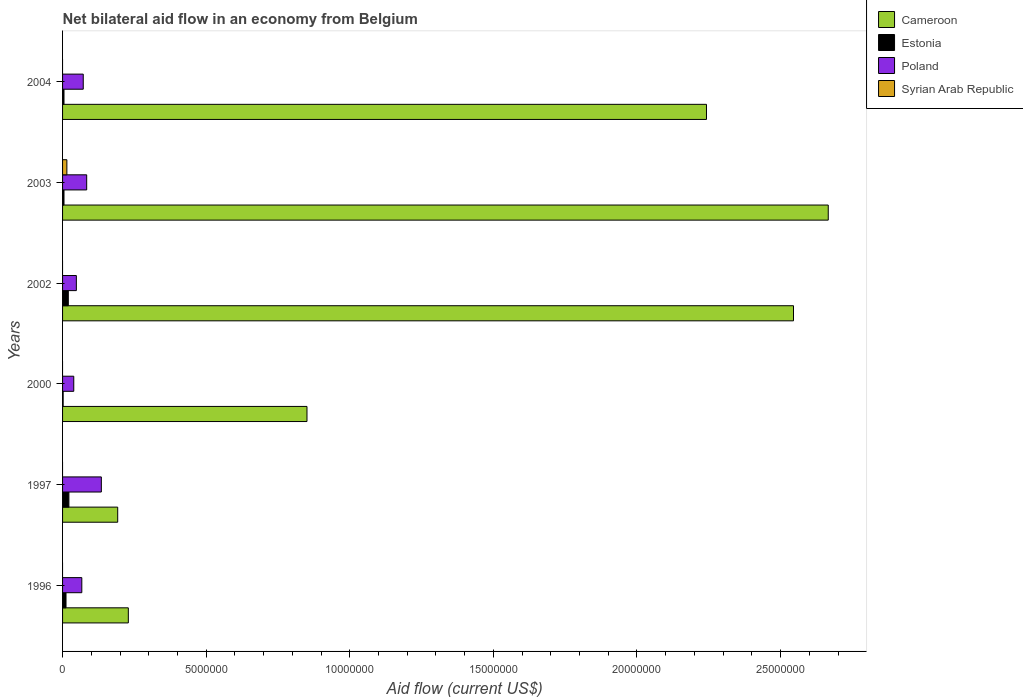How many different coloured bars are there?
Provide a short and direct response. 4. How many groups of bars are there?
Provide a short and direct response. 6. In how many cases, is the number of bars for a given year not equal to the number of legend labels?
Your response must be concise. 5. What is the net bilateral aid flow in Cameroon in 2003?
Offer a terse response. 2.67e+07. What is the total net bilateral aid flow in Cameroon in the graph?
Give a very brief answer. 8.72e+07. What is the average net bilateral aid flow in Cameroon per year?
Keep it short and to the point. 1.45e+07. In the year 2003, what is the difference between the net bilateral aid flow in Poland and net bilateral aid flow in Syrian Arab Republic?
Give a very brief answer. 6.90e+05. In how many years, is the net bilateral aid flow in Cameroon greater than 2000000 US$?
Offer a very short reply. 5. What is the ratio of the net bilateral aid flow in Cameroon in 1997 to that in 2003?
Provide a succinct answer. 0.07. Is the net bilateral aid flow in Estonia in 2000 less than that in 2004?
Keep it short and to the point. Yes. What is the difference between the highest and the second highest net bilateral aid flow in Cameroon?
Offer a very short reply. 1.21e+06. What is the difference between the highest and the lowest net bilateral aid flow in Estonia?
Offer a very short reply. 2.00e+05. In how many years, is the net bilateral aid flow in Estonia greater than the average net bilateral aid flow in Estonia taken over all years?
Make the answer very short. 3. Is it the case that in every year, the sum of the net bilateral aid flow in Estonia and net bilateral aid flow in Syrian Arab Republic is greater than the sum of net bilateral aid flow in Poland and net bilateral aid flow in Cameroon?
Your answer should be compact. No. Is it the case that in every year, the sum of the net bilateral aid flow in Cameroon and net bilateral aid flow in Poland is greater than the net bilateral aid flow in Syrian Arab Republic?
Offer a very short reply. Yes. How many bars are there?
Make the answer very short. 19. Are all the bars in the graph horizontal?
Offer a very short reply. Yes. How many years are there in the graph?
Ensure brevity in your answer.  6. Are the values on the major ticks of X-axis written in scientific E-notation?
Provide a succinct answer. No. Does the graph contain any zero values?
Ensure brevity in your answer.  Yes. Where does the legend appear in the graph?
Offer a very short reply. Top right. How many legend labels are there?
Your answer should be very brief. 4. How are the legend labels stacked?
Keep it short and to the point. Vertical. What is the title of the graph?
Provide a succinct answer. Net bilateral aid flow in an economy from Belgium. What is the label or title of the Y-axis?
Offer a very short reply. Years. What is the Aid flow (current US$) in Cameroon in 1996?
Keep it short and to the point. 2.29e+06. What is the Aid flow (current US$) in Poland in 1996?
Offer a very short reply. 6.70e+05. What is the Aid flow (current US$) in Syrian Arab Republic in 1996?
Your answer should be very brief. 0. What is the Aid flow (current US$) in Cameroon in 1997?
Your answer should be compact. 1.92e+06. What is the Aid flow (current US$) in Poland in 1997?
Your response must be concise. 1.35e+06. What is the Aid flow (current US$) of Cameroon in 2000?
Provide a short and direct response. 8.51e+06. What is the Aid flow (current US$) in Estonia in 2000?
Keep it short and to the point. 2.00e+04. What is the Aid flow (current US$) in Poland in 2000?
Keep it short and to the point. 3.90e+05. What is the Aid flow (current US$) in Cameroon in 2002?
Offer a very short reply. 2.54e+07. What is the Aid flow (current US$) of Syrian Arab Republic in 2002?
Your answer should be compact. 0. What is the Aid flow (current US$) in Cameroon in 2003?
Offer a terse response. 2.67e+07. What is the Aid flow (current US$) of Poland in 2003?
Provide a short and direct response. 8.40e+05. What is the Aid flow (current US$) in Syrian Arab Republic in 2003?
Offer a very short reply. 1.50e+05. What is the Aid flow (current US$) of Cameroon in 2004?
Give a very brief answer. 2.24e+07. What is the Aid flow (current US$) in Estonia in 2004?
Offer a terse response. 5.00e+04. What is the Aid flow (current US$) in Poland in 2004?
Your answer should be compact. 7.20e+05. What is the Aid flow (current US$) in Syrian Arab Republic in 2004?
Offer a terse response. 0. Across all years, what is the maximum Aid flow (current US$) of Cameroon?
Give a very brief answer. 2.67e+07. Across all years, what is the maximum Aid flow (current US$) in Poland?
Give a very brief answer. 1.35e+06. Across all years, what is the maximum Aid flow (current US$) in Syrian Arab Republic?
Give a very brief answer. 1.50e+05. Across all years, what is the minimum Aid flow (current US$) in Cameroon?
Keep it short and to the point. 1.92e+06. What is the total Aid flow (current US$) in Cameroon in the graph?
Keep it short and to the point. 8.72e+07. What is the total Aid flow (current US$) in Poland in the graph?
Provide a succinct answer. 4.45e+06. What is the total Aid flow (current US$) in Syrian Arab Republic in the graph?
Keep it short and to the point. 1.50e+05. What is the difference between the Aid flow (current US$) of Cameroon in 1996 and that in 1997?
Keep it short and to the point. 3.70e+05. What is the difference between the Aid flow (current US$) in Estonia in 1996 and that in 1997?
Ensure brevity in your answer.  -1.00e+05. What is the difference between the Aid flow (current US$) of Poland in 1996 and that in 1997?
Provide a short and direct response. -6.80e+05. What is the difference between the Aid flow (current US$) in Cameroon in 1996 and that in 2000?
Make the answer very short. -6.22e+06. What is the difference between the Aid flow (current US$) of Cameroon in 1996 and that in 2002?
Keep it short and to the point. -2.32e+07. What is the difference between the Aid flow (current US$) in Poland in 1996 and that in 2002?
Keep it short and to the point. 1.90e+05. What is the difference between the Aid flow (current US$) of Cameroon in 1996 and that in 2003?
Offer a terse response. -2.44e+07. What is the difference between the Aid flow (current US$) of Poland in 1996 and that in 2003?
Provide a succinct answer. -1.70e+05. What is the difference between the Aid flow (current US$) of Cameroon in 1996 and that in 2004?
Offer a terse response. -2.01e+07. What is the difference between the Aid flow (current US$) in Estonia in 1996 and that in 2004?
Give a very brief answer. 7.00e+04. What is the difference between the Aid flow (current US$) of Poland in 1996 and that in 2004?
Keep it short and to the point. -5.00e+04. What is the difference between the Aid flow (current US$) of Cameroon in 1997 and that in 2000?
Give a very brief answer. -6.59e+06. What is the difference between the Aid flow (current US$) of Estonia in 1997 and that in 2000?
Your response must be concise. 2.00e+05. What is the difference between the Aid flow (current US$) of Poland in 1997 and that in 2000?
Your answer should be compact. 9.60e+05. What is the difference between the Aid flow (current US$) of Cameroon in 1997 and that in 2002?
Ensure brevity in your answer.  -2.35e+07. What is the difference between the Aid flow (current US$) of Poland in 1997 and that in 2002?
Your response must be concise. 8.70e+05. What is the difference between the Aid flow (current US$) in Cameroon in 1997 and that in 2003?
Make the answer very short. -2.47e+07. What is the difference between the Aid flow (current US$) of Poland in 1997 and that in 2003?
Offer a very short reply. 5.10e+05. What is the difference between the Aid flow (current US$) of Cameroon in 1997 and that in 2004?
Make the answer very short. -2.05e+07. What is the difference between the Aid flow (current US$) in Poland in 1997 and that in 2004?
Provide a succinct answer. 6.30e+05. What is the difference between the Aid flow (current US$) in Cameroon in 2000 and that in 2002?
Offer a very short reply. -1.69e+07. What is the difference between the Aid flow (current US$) of Estonia in 2000 and that in 2002?
Give a very brief answer. -1.80e+05. What is the difference between the Aid flow (current US$) of Cameroon in 2000 and that in 2003?
Keep it short and to the point. -1.82e+07. What is the difference between the Aid flow (current US$) in Poland in 2000 and that in 2003?
Give a very brief answer. -4.50e+05. What is the difference between the Aid flow (current US$) of Cameroon in 2000 and that in 2004?
Make the answer very short. -1.39e+07. What is the difference between the Aid flow (current US$) in Poland in 2000 and that in 2004?
Your answer should be compact. -3.30e+05. What is the difference between the Aid flow (current US$) in Cameroon in 2002 and that in 2003?
Offer a terse response. -1.21e+06. What is the difference between the Aid flow (current US$) in Poland in 2002 and that in 2003?
Offer a terse response. -3.60e+05. What is the difference between the Aid flow (current US$) of Cameroon in 2002 and that in 2004?
Make the answer very short. 3.03e+06. What is the difference between the Aid flow (current US$) in Poland in 2002 and that in 2004?
Offer a terse response. -2.40e+05. What is the difference between the Aid flow (current US$) of Cameroon in 2003 and that in 2004?
Offer a terse response. 4.24e+06. What is the difference between the Aid flow (current US$) of Estonia in 2003 and that in 2004?
Make the answer very short. 0. What is the difference between the Aid flow (current US$) in Cameroon in 1996 and the Aid flow (current US$) in Estonia in 1997?
Give a very brief answer. 2.07e+06. What is the difference between the Aid flow (current US$) in Cameroon in 1996 and the Aid flow (current US$) in Poland in 1997?
Ensure brevity in your answer.  9.40e+05. What is the difference between the Aid flow (current US$) in Estonia in 1996 and the Aid flow (current US$) in Poland in 1997?
Keep it short and to the point. -1.23e+06. What is the difference between the Aid flow (current US$) of Cameroon in 1996 and the Aid flow (current US$) of Estonia in 2000?
Your response must be concise. 2.27e+06. What is the difference between the Aid flow (current US$) in Cameroon in 1996 and the Aid flow (current US$) in Poland in 2000?
Give a very brief answer. 1.90e+06. What is the difference between the Aid flow (current US$) of Estonia in 1996 and the Aid flow (current US$) of Poland in 2000?
Give a very brief answer. -2.70e+05. What is the difference between the Aid flow (current US$) in Cameroon in 1996 and the Aid flow (current US$) in Estonia in 2002?
Your response must be concise. 2.09e+06. What is the difference between the Aid flow (current US$) of Cameroon in 1996 and the Aid flow (current US$) of Poland in 2002?
Offer a very short reply. 1.81e+06. What is the difference between the Aid flow (current US$) in Estonia in 1996 and the Aid flow (current US$) in Poland in 2002?
Your answer should be compact. -3.60e+05. What is the difference between the Aid flow (current US$) of Cameroon in 1996 and the Aid flow (current US$) of Estonia in 2003?
Make the answer very short. 2.24e+06. What is the difference between the Aid flow (current US$) of Cameroon in 1996 and the Aid flow (current US$) of Poland in 2003?
Offer a very short reply. 1.45e+06. What is the difference between the Aid flow (current US$) in Cameroon in 1996 and the Aid flow (current US$) in Syrian Arab Republic in 2003?
Your answer should be very brief. 2.14e+06. What is the difference between the Aid flow (current US$) of Estonia in 1996 and the Aid flow (current US$) of Poland in 2003?
Offer a very short reply. -7.20e+05. What is the difference between the Aid flow (current US$) in Estonia in 1996 and the Aid flow (current US$) in Syrian Arab Republic in 2003?
Your response must be concise. -3.00e+04. What is the difference between the Aid flow (current US$) of Poland in 1996 and the Aid flow (current US$) of Syrian Arab Republic in 2003?
Ensure brevity in your answer.  5.20e+05. What is the difference between the Aid flow (current US$) of Cameroon in 1996 and the Aid flow (current US$) of Estonia in 2004?
Make the answer very short. 2.24e+06. What is the difference between the Aid flow (current US$) of Cameroon in 1996 and the Aid flow (current US$) of Poland in 2004?
Give a very brief answer. 1.57e+06. What is the difference between the Aid flow (current US$) in Estonia in 1996 and the Aid flow (current US$) in Poland in 2004?
Give a very brief answer. -6.00e+05. What is the difference between the Aid flow (current US$) in Cameroon in 1997 and the Aid flow (current US$) in Estonia in 2000?
Ensure brevity in your answer.  1.90e+06. What is the difference between the Aid flow (current US$) of Cameroon in 1997 and the Aid flow (current US$) of Poland in 2000?
Provide a short and direct response. 1.53e+06. What is the difference between the Aid flow (current US$) in Estonia in 1997 and the Aid flow (current US$) in Poland in 2000?
Make the answer very short. -1.70e+05. What is the difference between the Aid flow (current US$) of Cameroon in 1997 and the Aid flow (current US$) of Estonia in 2002?
Keep it short and to the point. 1.72e+06. What is the difference between the Aid flow (current US$) in Cameroon in 1997 and the Aid flow (current US$) in Poland in 2002?
Your answer should be very brief. 1.44e+06. What is the difference between the Aid flow (current US$) in Estonia in 1997 and the Aid flow (current US$) in Poland in 2002?
Offer a very short reply. -2.60e+05. What is the difference between the Aid flow (current US$) in Cameroon in 1997 and the Aid flow (current US$) in Estonia in 2003?
Your response must be concise. 1.87e+06. What is the difference between the Aid flow (current US$) in Cameroon in 1997 and the Aid flow (current US$) in Poland in 2003?
Your answer should be very brief. 1.08e+06. What is the difference between the Aid flow (current US$) in Cameroon in 1997 and the Aid flow (current US$) in Syrian Arab Republic in 2003?
Offer a very short reply. 1.77e+06. What is the difference between the Aid flow (current US$) of Estonia in 1997 and the Aid flow (current US$) of Poland in 2003?
Ensure brevity in your answer.  -6.20e+05. What is the difference between the Aid flow (current US$) of Estonia in 1997 and the Aid flow (current US$) of Syrian Arab Republic in 2003?
Make the answer very short. 7.00e+04. What is the difference between the Aid flow (current US$) of Poland in 1997 and the Aid flow (current US$) of Syrian Arab Republic in 2003?
Offer a terse response. 1.20e+06. What is the difference between the Aid flow (current US$) in Cameroon in 1997 and the Aid flow (current US$) in Estonia in 2004?
Offer a very short reply. 1.87e+06. What is the difference between the Aid flow (current US$) of Cameroon in 1997 and the Aid flow (current US$) of Poland in 2004?
Ensure brevity in your answer.  1.20e+06. What is the difference between the Aid flow (current US$) of Estonia in 1997 and the Aid flow (current US$) of Poland in 2004?
Your answer should be compact. -5.00e+05. What is the difference between the Aid flow (current US$) of Cameroon in 2000 and the Aid flow (current US$) of Estonia in 2002?
Your response must be concise. 8.31e+06. What is the difference between the Aid flow (current US$) in Cameroon in 2000 and the Aid flow (current US$) in Poland in 2002?
Offer a very short reply. 8.03e+06. What is the difference between the Aid flow (current US$) in Estonia in 2000 and the Aid flow (current US$) in Poland in 2002?
Offer a terse response. -4.60e+05. What is the difference between the Aid flow (current US$) of Cameroon in 2000 and the Aid flow (current US$) of Estonia in 2003?
Keep it short and to the point. 8.46e+06. What is the difference between the Aid flow (current US$) of Cameroon in 2000 and the Aid flow (current US$) of Poland in 2003?
Ensure brevity in your answer.  7.67e+06. What is the difference between the Aid flow (current US$) in Cameroon in 2000 and the Aid flow (current US$) in Syrian Arab Republic in 2003?
Your response must be concise. 8.36e+06. What is the difference between the Aid flow (current US$) of Estonia in 2000 and the Aid flow (current US$) of Poland in 2003?
Give a very brief answer. -8.20e+05. What is the difference between the Aid flow (current US$) of Estonia in 2000 and the Aid flow (current US$) of Syrian Arab Republic in 2003?
Give a very brief answer. -1.30e+05. What is the difference between the Aid flow (current US$) in Cameroon in 2000 and the Aid flow (current US$) in Estonia in 2004?
Make the answer very short. 8.46e+06. What is the difference between the Aid flow (current US$) in Cameroon in 2000 and the Aid flow (current US$) in Poland in 2004?
Provide a short and direct response. 7.79e+06. What is the difference between the Aid flow (current US$) in Estonia in 2000 and the Aid flow (current US$) in Poland in 2004?
Your response must be concise. -7.00e+05. What is the difference between the Aid flow (current US$) in Cameroon in 2002 and the Aid flow (current US$) in Estonia in 2003?
Keep it short and to the point. 2.54e+07. What is the difference between the Aid flow (current US$) in Cameroon in 2002 and the Aid flow (current US$) in Poland in 2003?
Make the answer very short. 2.46e+07. What is the difference between the Aid flow (current US$) in Cameroon in 2002 and the Aid flow (current US$) in Syrian Arab Republic in 2003?
Make the answer very short. 2.53e+07. What is the difference between the Aid flow (current US$) of Estonia in 2002 and the Aid flow (current US$) of Poland in 2003?
Ensure brevity in your answer.  -6.40e+05. What is the difference between the Aid flow (current US$) of Poland in 2002 and the Aid flow (current US$) of Syrian Arab Republic in 2003?
Your answer should be very brief. 3.30e+05. What is the difference between the Aid flow (current US$) in Cameroon in 2002 and the Aid flow (current US$) in Estonia in 2004?
Provide a short and direct response. 2.54e+07. What is the difference between the Aid flow (current US$) in Cameroon in 2002 and the Aid flow (current US$) in Poland in 2004?
Provide a short and direct response. 2.47e+07. What is the difference between the Aid flow (current US$) in Estonia in 2002 and the Aid flow (current US$) in Poland in 2004?
Ensure brevity in your answer.  -5.20e+05. What is the difference between the Aid flow (current US$) of Cameroon in 2003 and the Aid flow (current US$) of Estonia in 2004?
Ensure brevity in your answer.  2.66e+07. What is the difference between the Aid flow (current US$) of Cameroon in 2003 and the Aid flow (current US$) of Poland in 2004?
Your answer should be compact. 2.59e+07. What is the difference between the Aid flow (current US$) of Estonia in 2003 and the Aid flow (current US$) of Poland in 2004?
Offer a very short reply. -6.70e+05. What is the average Aid flow (current US$) of Cameroon per year?
Provide a succinct answer. 1.45e+07. What is the average Aid flow (current US$) in Poland per year?
Offer a very short reply. 7.42e+05. What is the average Aid flow (current US$) in Syrian Arab Republic per year?
Keep it short and to the point. 2.50e+04. In the year 1996, what is the difference between the Aid flow (current US$) of Cameroon and Aid flow (current US$) of Estonia?
Your response must be concise. 2.17e+06. In the year 1996, what is the difference between the Aid flow (current US$) of Cameroon and Aid flow (current US$) of Poland?
Make the answer very short. 1.62e+06. In the year 1996, what is the difference between the Aid flow (current US$) in Estonia and Aid flow (current US$) in Poland?
Give a very brief answer. -5.50e+05. In the year 1997, what is the difference between the Aid flow (current US$) of Cameroon and Aid flow (current US$) of Estonia?
Keep it short and to the point. 1.70e+06. In the year 1997, what is the difference between the Aid flow (current US$) of Cameroon and Aid flow (current US$) of Poland?
Keep it short and to the point. 5.70e+05. In the year 1997, what is the difference between the Aid flow (current US$) of Estonia and Aid flow (current US$) of Poland?
Offer a terse response. -1.13e+06. In the year 2000, what is the difference between the Aid flow (current US$) of Cameroon and Aid flow (current US$) of Estonia?
Keep it short and to the point. 8.49e+06. In the year 2000, what is the difference between the Aid flow (current US$) in Cameroon and Aid flow (current US$) in Poland?
Your response must be concise. 8.12e+06. In the year 2000, what is the difference between the Aid flow (current US$) in Estonia and Aid flow (current US$) in Poland?
Make the answer very short. -3.70e+05. In the year 2002, what is the difference between the Aid flow (current US$) of Cameroon and Aid flow (current US$) of Estonia?
Offer a very short reply. 2.52e+07. In the year 2002, what is the difference between the Aid flow (current US$) of Cameroon and Aid flow (current US$) of Poland?
Keep it short and to the point. 2.50e+07. In the year 2002, what is the difference between the Aid flow (current US$) of Estonia and Aid flow (current US$) of Poland?
Your answer should be very brief. -2.80e+05. In the year 2003, what is the difference between the Aid flow (current US$) in Cameroon and Aid flow (current US$) in Estonia?
Make the answer very short. 2.66e+07. In the year 2003, what is the difference between the Aid flow (current US$) of Cameroon and Aid flow (current US$) of Poland?
Provide a succinct answer. 2.58e+07. In the year 2003, what is the difference between the Aid flow (current US$) of Cameroon and Aid flow (current US$) of Syrian Arab Republic?
Provide a succinct answer. 2.65e+07. In the year 2003, what is the difference between the Aid flow (current US$) in Estonia and Aid flow (current US$) in Poland?
Offer a very short reply. -7.90e+05. In the year 2003, what is the difference between the Aid flow (current US$) in Estonia and Aid flow (current US$) in Syrian Arab Republic?
Make the answer very short. -1.00e+05. In the year 2003, what is the difference between the Aid flow (current US$) in Poland and Aid flow (current US$) in Syrian Arab Republic?
Your answer should be compact. 6.90e+05. In the year 2004, what is the difference between the Aid flow (current US$) in Cameroon and Aid flow (current US$) in Estonia?
Provide a short and direct response. 2.24e+07. In the year 2004, what is the difference between the Aid flow (current US$) of Cameroon and Aid flow (current US$) of Poland?
Make the answer very short. 2.17e+07. In the year 2004, what is the difference between the Aid flow (current US$) of Estonia and Aid flow (current US$) of Poland?
Your answer should be compact. -6.70e+05. What is the ratio of the Aid flow (current US$) in Cameroon in 1996 to that in 1997?
Provide a short and direct response. 1.19. What is the ratio of the Aid flow (current US$) in Estonia in 1996 to that in 1997?
Your answer should be compact. 0.55. What is the ratio of the Aid flow (current US$) of Poland in 1996 to that in 1997?
Ensure brevity in your answer.  0.5. What is the ratio of the Aid flow (current US$) in Cameroon in 1996 to that in 2000?
Keep it short and to the point. 0.27. What is the ratio of the Aid flow (current US$) of Poland in 1996 to that in 2000?
Provide a short and direct response. 1.72. What is the ratio of the Aid flow (current US$) of Cameroon in 1996 to that in 2002?
Your answer should be compact. 0.09. What is the ratio of the Aid flow (current US$) in Poland in 1996 to that in 2002?
Your answer should be very brief. 1.4. What is the ratio of the Aid flow (current US$) of Cameroon in 1996 to that in 2003?
Provide a succinct answer. 0.09. What is the ratio of the Aid flow (current US$) in Poland in 1996 to that in 2003?
Your response must be concise. 0.8. What is the ratio of the Aid flow (current US$) in Cameroon in 1996 to that in 2004?
Provide a short and direct response. 0.1. What is the ratio of the Aid flow (current US$) in Estonia in 1996 to that in 2004?
Your answer should be compact. 2.4. What is the ratio of the Aid flow (current US$) in Poland in 1996 to that in 2004?
Give a very brief answer. 0.93. What is the ratio of the Aid flow (current US$) of Cameroon in 1997 to that in 2000?
Your response must be concise. 0.23. What is the ratio of the Aid flow (current US$) in Poland in 1997 to that in 2000?
Offer a terse response. 3.46. What is the ratio of the Aid flow (current US$) of Cameroon in 1997 to that in 2002?
Keep it short and to the point. 0.08. What is the ratio of the Aid flow (current US$) in Poland in 1997 to that in 2002?
Provide a succinct answer. 2.81. What is the ratio of the Aid flow (current US$) in Cameroon in 1997 to that in 2003?
Offer a very short reply. 0.07. What is the ratio of the Aid flow (current US$) in Estonia in 1997 to that in 2003?
Your answer should be very brief. 4.4. What is the ratio of the Aid flow (current US$) in Poland in 1997 to that in 2003?
Your answer should be compact. 1.61. What is the ratio of the Aid flow (current US$) in Cameroon in 1997 to that in 2004?
Offer a terse response. 0.09. What is the ratio of the Aid flow (current US$) of Estonia in 1997 to that in 2004?
Your response must be concise. 4.4. What is the ratio of the Aid flow (current US$) of Poland in 1997 to that in 2004?
Make the answer very short. 1.88. What is the ratio of the Aid flow (current US$) in Cameroon in 2000 to that in 2002?
Your response must be concise. 0.33. What is the ratio of the Aid flow (current US$) in Poland in 2000 to that in 2002?
Ensure brevity in your answer.  0.81. What is the ratio of the Aid flow (current US$) in Cameroon in 2000 to that in 2003?
Provide a short and direct response. 0.32. What is the ratio of the Aid flow (current US$) of Estonia in 2000 to that in 2003?
Make the answer very short. 0.4. What is the ratio of the Aid flow (current US$) of Poland in 2000 to that in 2003?
Give a very brief answer. 0.46. What is the ratio of the Aid flow (current US$) in Cameroon in 2000 to that in 2004?
Your answer should be very brief. 0.38. What is the ratio of the Aid flow (current US$) in Poland in 2000 to that in 2004?
Provide a succinct answer. 0.54. What is the ratio of the Aid flow (current US$) in Cameroon in 2002 to that in 2003?
Offer a very short reply. 0.95. What is the ratio of the Aid flow (current US$) in Estonia in 2002 to that in 2003?
Offer a terse response. 4. What is the ratio of the Aid flow (current US$) in Poland in 2002 to that in 2003?
Your response must be concise. 0.57. What is the ratio of the Aid flow (current US$) in Cameroon in 2002 to that in 2004?
Offer a very short reply. 1.14. What is the ratio of the Aid flow (current US$) in Estonia in 2002 to that in 2004?
Your answer should be very brief. 4. What is the ratio of the Aid flow (current US$) of Poland in 2002 to that in 2004?
Your response must be concise. 0.67. What is the ratio of the Aid flow (current US$) of Cameroon in 2003 to that in 2004?
Offer a very short reply. 1.19. What is the ratio of the Aid flow (current US$) in Estonia in 2003 to that in 2004?
Your response must be concise. 1. What is the ratio of the Aid flow (current US$) in Poland in 2003 to that in 2004?
Provide a short and direct response. 1.17. What is the difference between the highest and the second highest Aid flow (current US$) in Cameroon?
Your answer should be very brief. 1.21e+06. What is the difference between the highest and the second highest Aid flow (current US$) of Poland?
Your answer should be compact. 5.10e+05. What is the difference between the highest and the lowest Aid flow (current US$) of Cameroon?
Offer a very short reply. 2.47e+07. What is the difference between the highest and the lowest Aid flow (current US$) of Poland?
Keep it short and to the point. 9.60e+05. What is the difference between the highest and the lowest Aid flow (current US$) of Syrian Arab Republic?
Make the answer very short. 1.50e+05. 